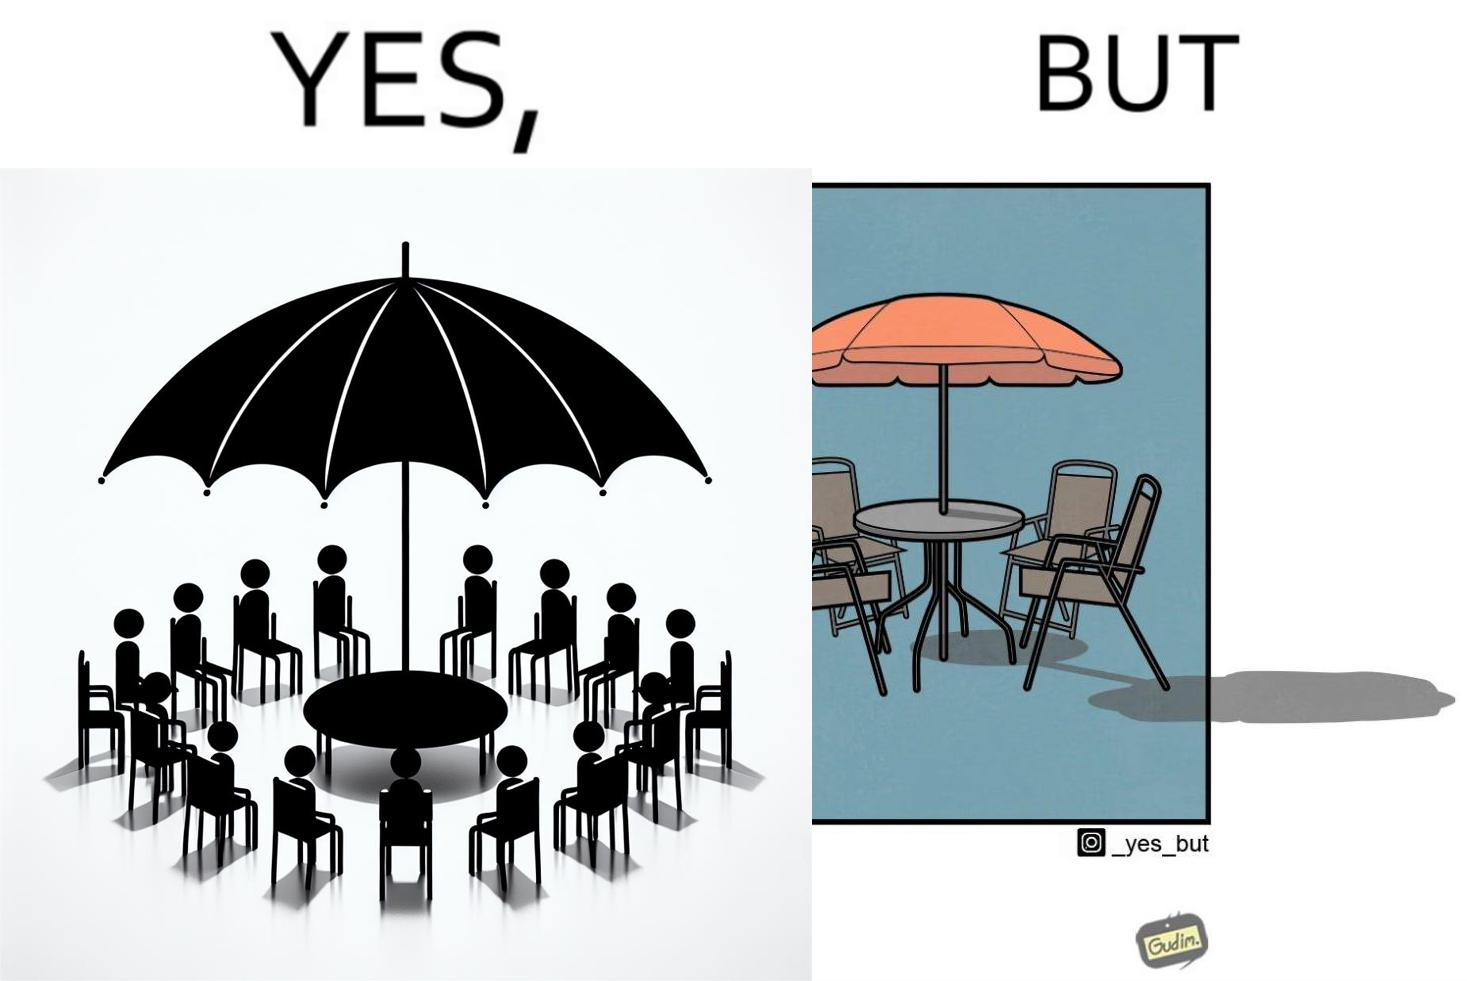Would you classify this image as satirical? Yes, this image is satirical. 